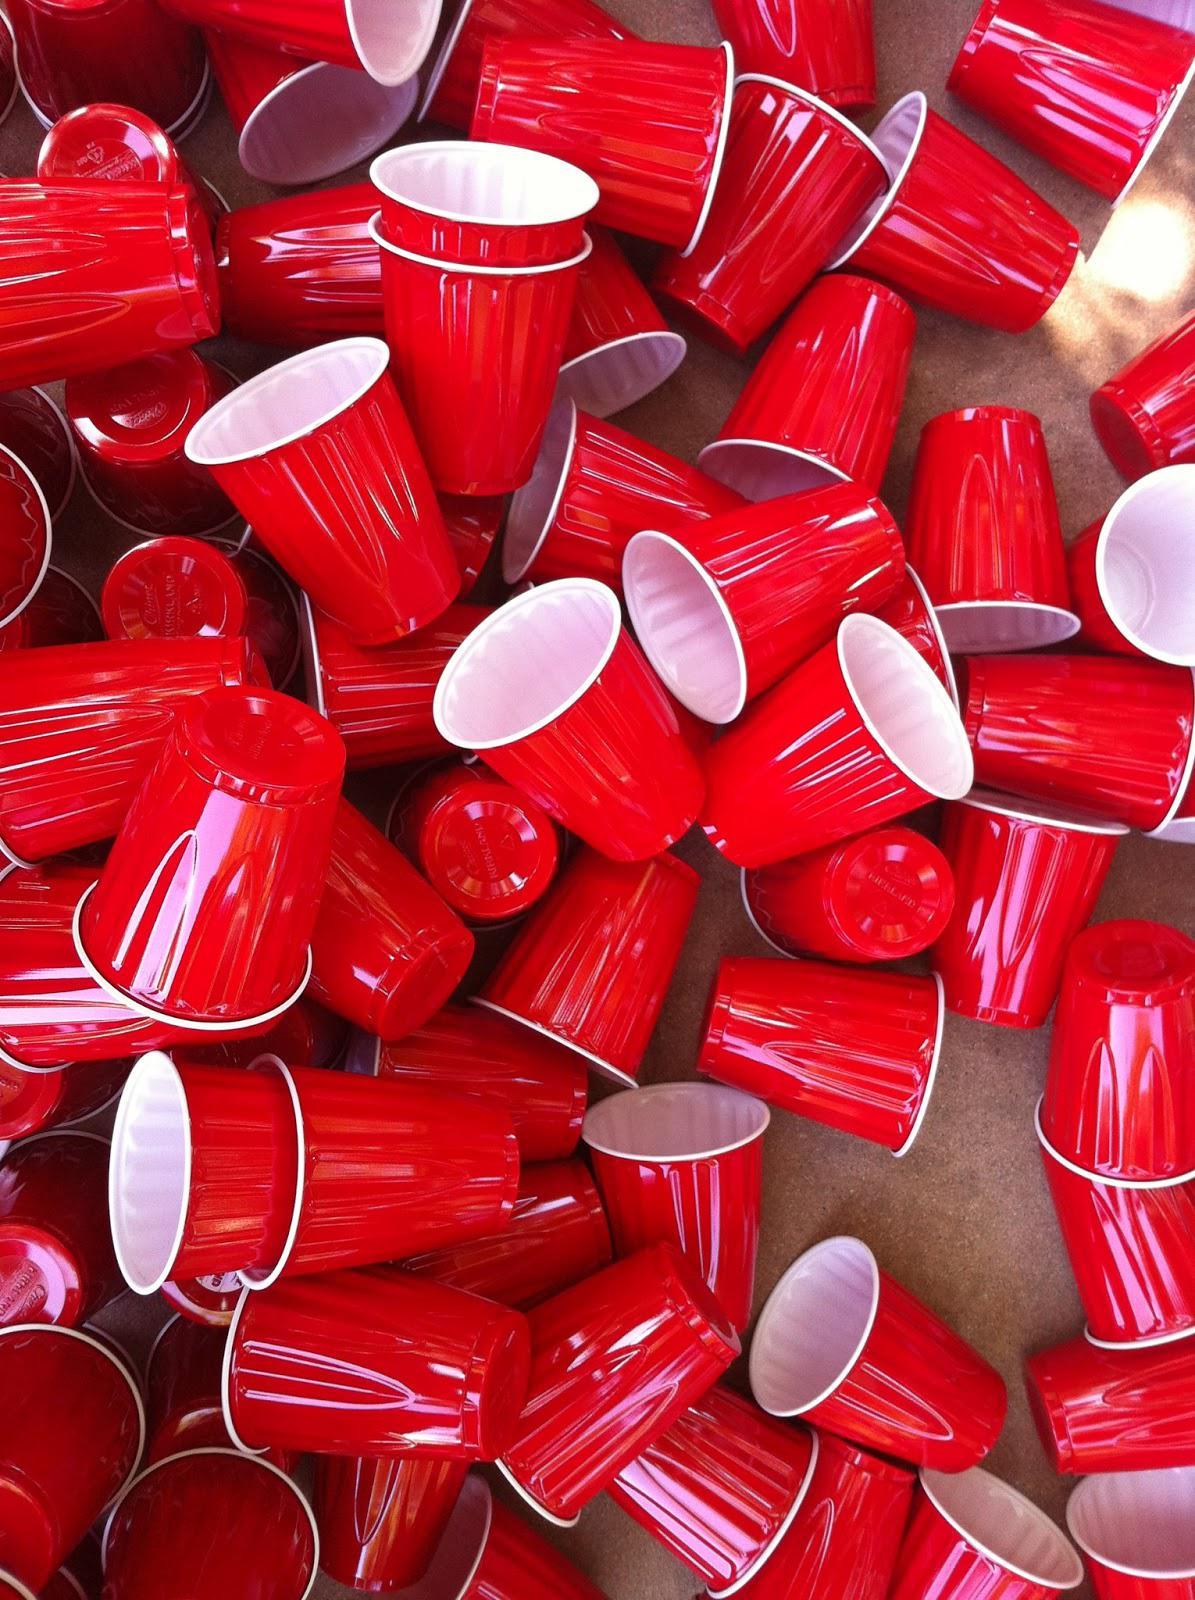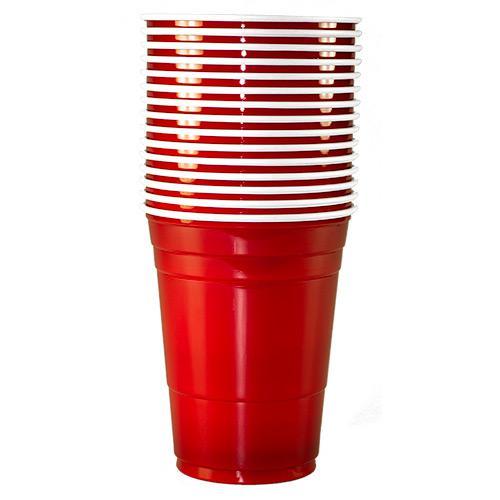The first image is the image on the left, the second image is the image on the right. Examine the images to the left and right. Is the description "Several red solo cups are stacked nested neatly inside each other." accurate? Answer yes or no. Yes. The first image is the image on the left, the second image is the image on the right. Considering the images on both sides, is "The left image features a tower of five stacked red plastic cups, and the right image includes rightside-up and upside-down red cups shapes." valid? Answer yes or no. No. 